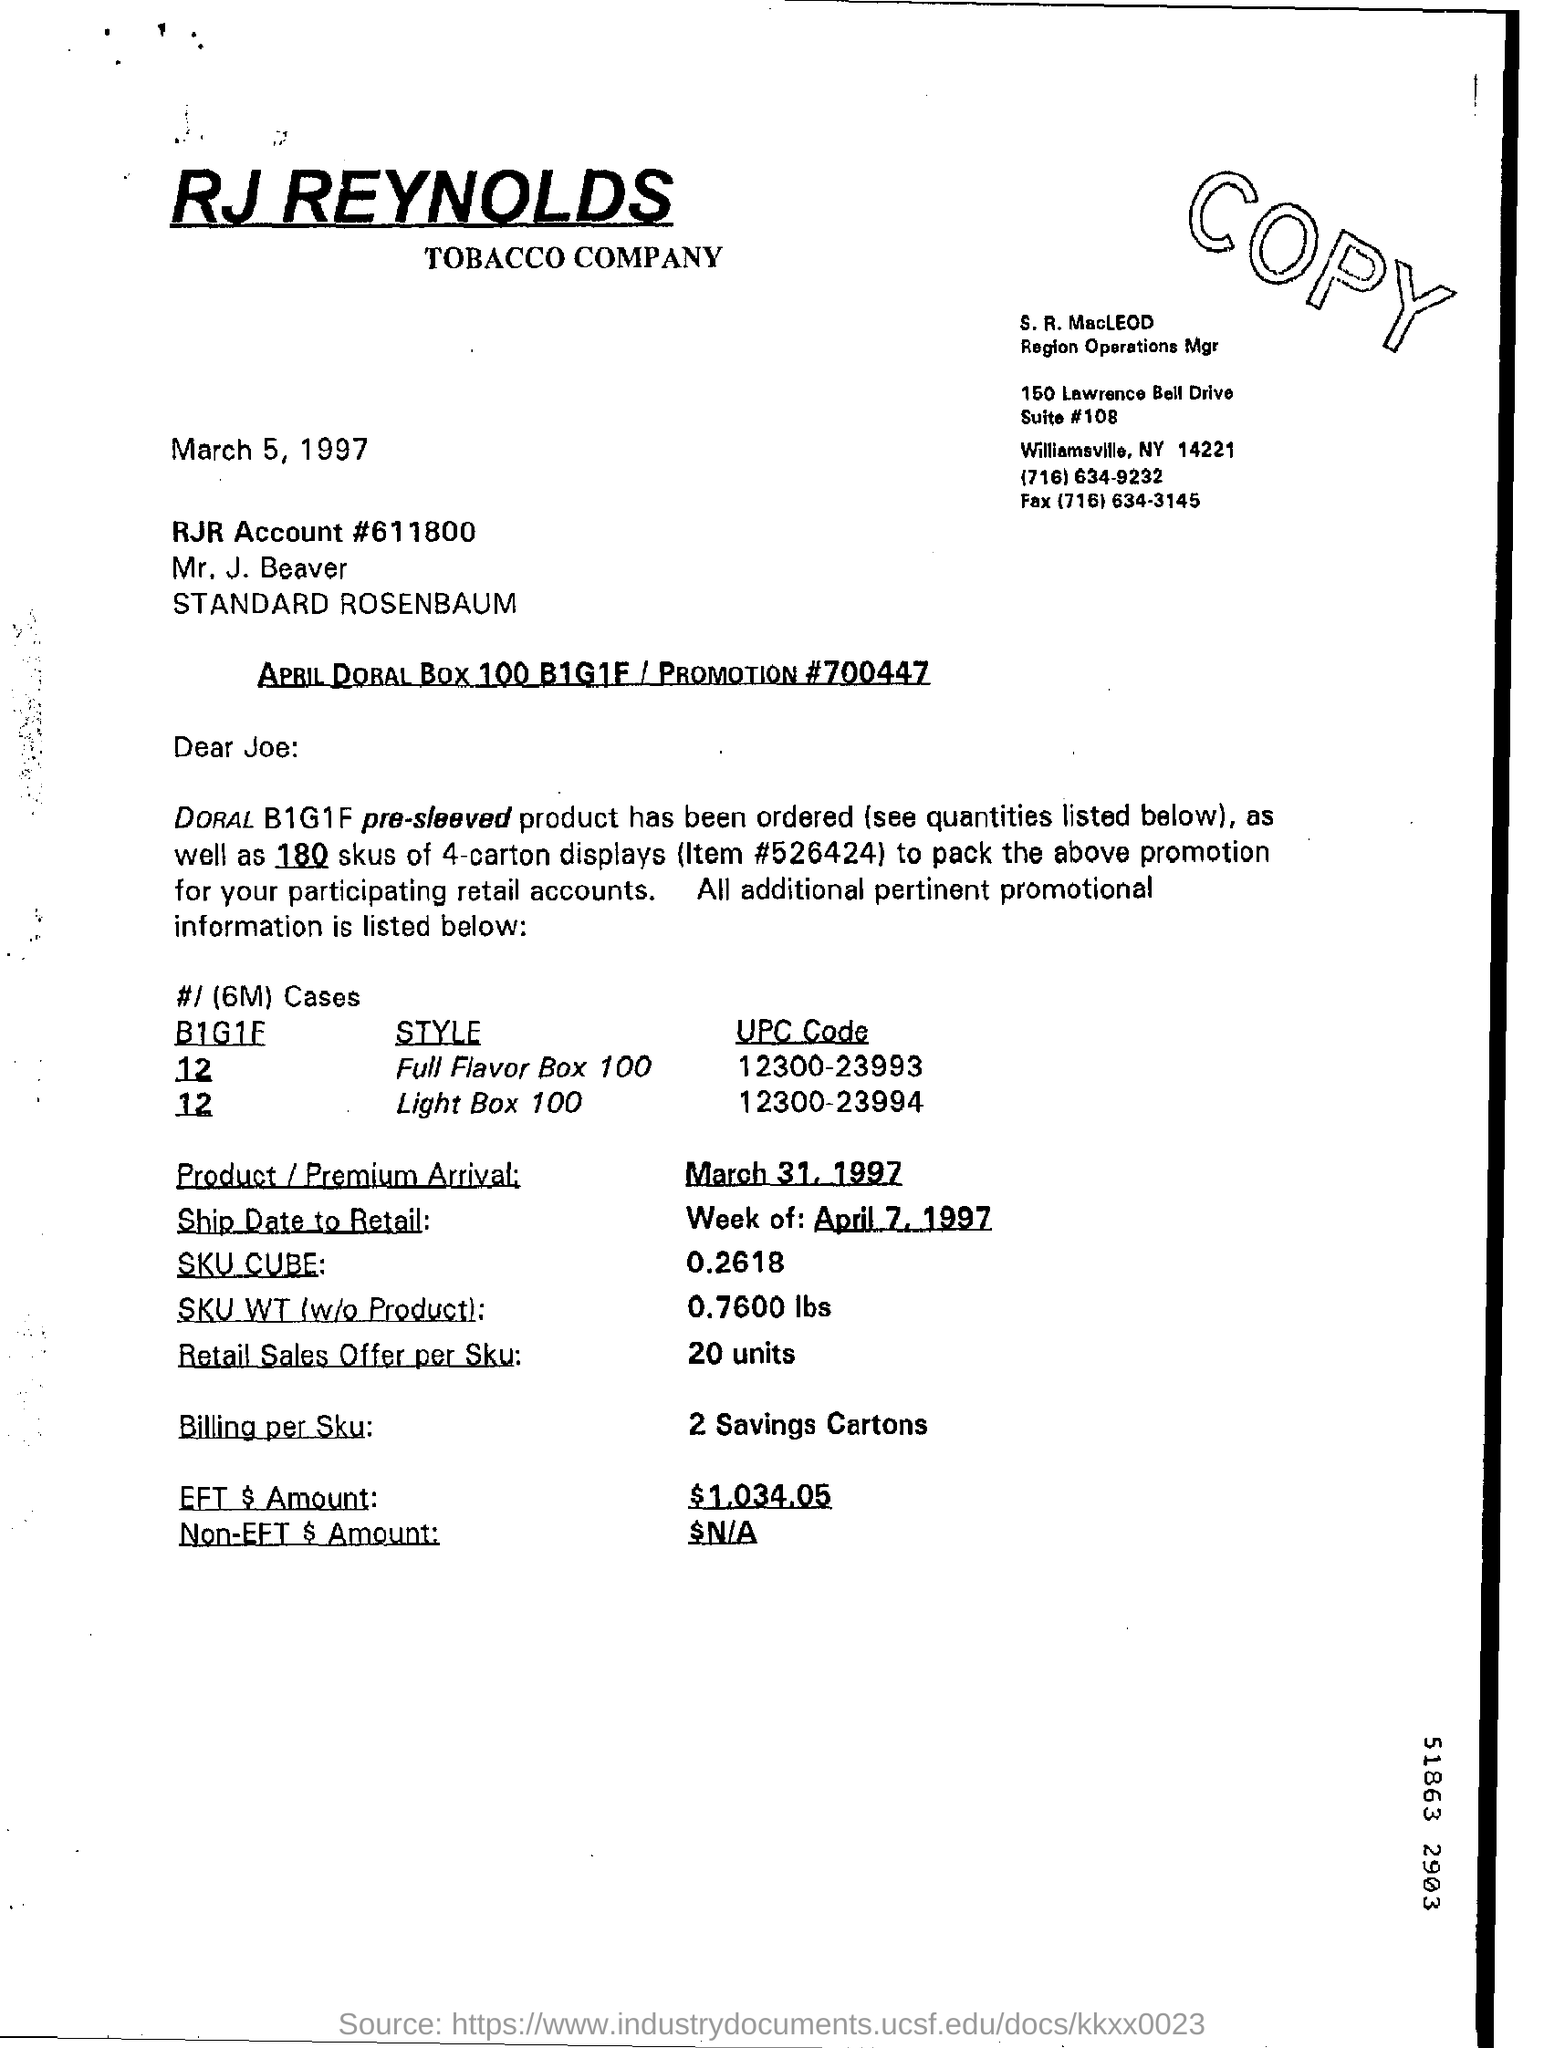What is the name of the tobacco company?
Offer a very short reply. RJ REYNOLDS TOBACCO COMPANY. What is the upc code for the style of full flavour box100
Offer a very short reply. 12300-23993. 